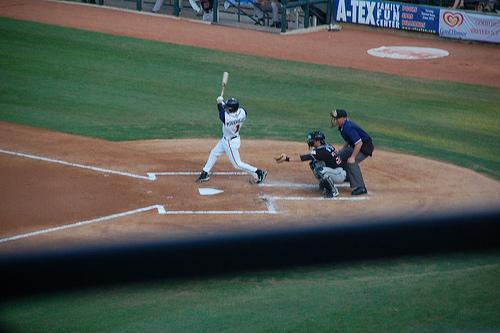How many people are pictured?
Give a very brief answer. 3. 